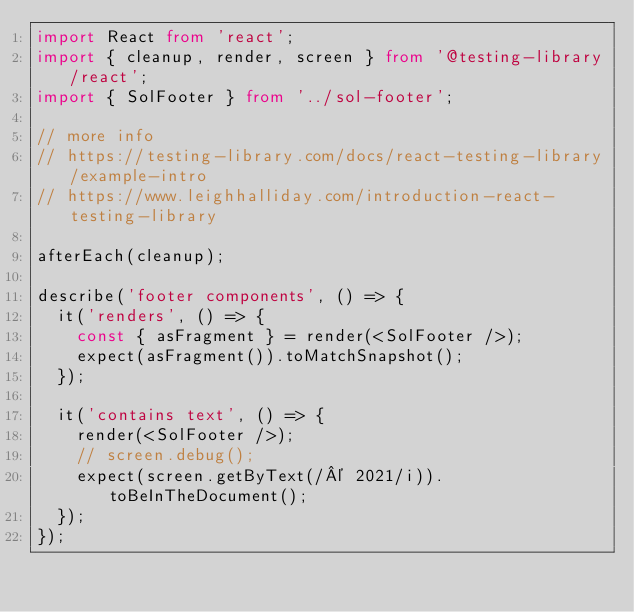Convert code to text. <code><loc_0><loc_0><loc_500><loc_500><_TypeScript_>import React from 'react';
import { cleanup, render, screen } from '@testing-library/react';
import { SolFooter } from '../sol-footer';

// more info
// https://testing-library.com/docs/react-testing-library/example-intro
// https://www.leighhalliday.com/introduction-react-testing-library

afterEach(cleanup);

describe('footer components', () => {
  it('renders', () => {
    const { asFragment } = render(<SolFooter />);
    expect(asFragment()).toMatchSnapshot();
  });

  it('contains text', () => {
    render(<SolFooter />);
    // screen.debug();
    expect(screen.getByText(/© 2021/i)).toBeInTheDocument();
  });
});
</code> 